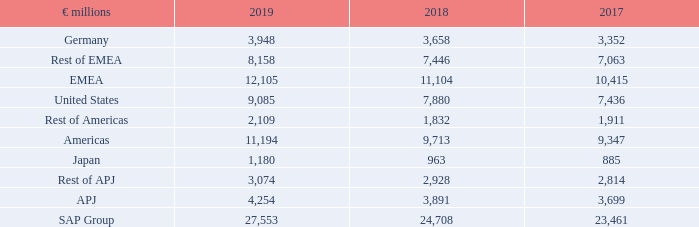Geographic Information
The amounts for revenue by region in the following tables are based on the location of customers. The regions in the following table are EMEA (Europe, Middle East, and Africa), Americas (North America and Latin America), and APJ (Asia Pacific Japan).
Total Revenue by Region
What is the amount for EMEA in 2019?
Answer scale should be: million. 12,105. What is the amount for APJ in 2018?
Answer scale should be: million. 3,891. What are the broad categories making up the total revenue by region? Emea, americas, apj. In which year was the amount for Germany the largest? 3,948>3,658>3,352
Answer: 2019. What was the change in APJ in 2019 from 2018?
Answer scale should be: million. 4,254-3,891
Answer: 363. What was the percentage change in APJ in 2019 from 2018?
Answer scale should be: percent. (4,254-3,891)/3,891
Answer: 9.33. 